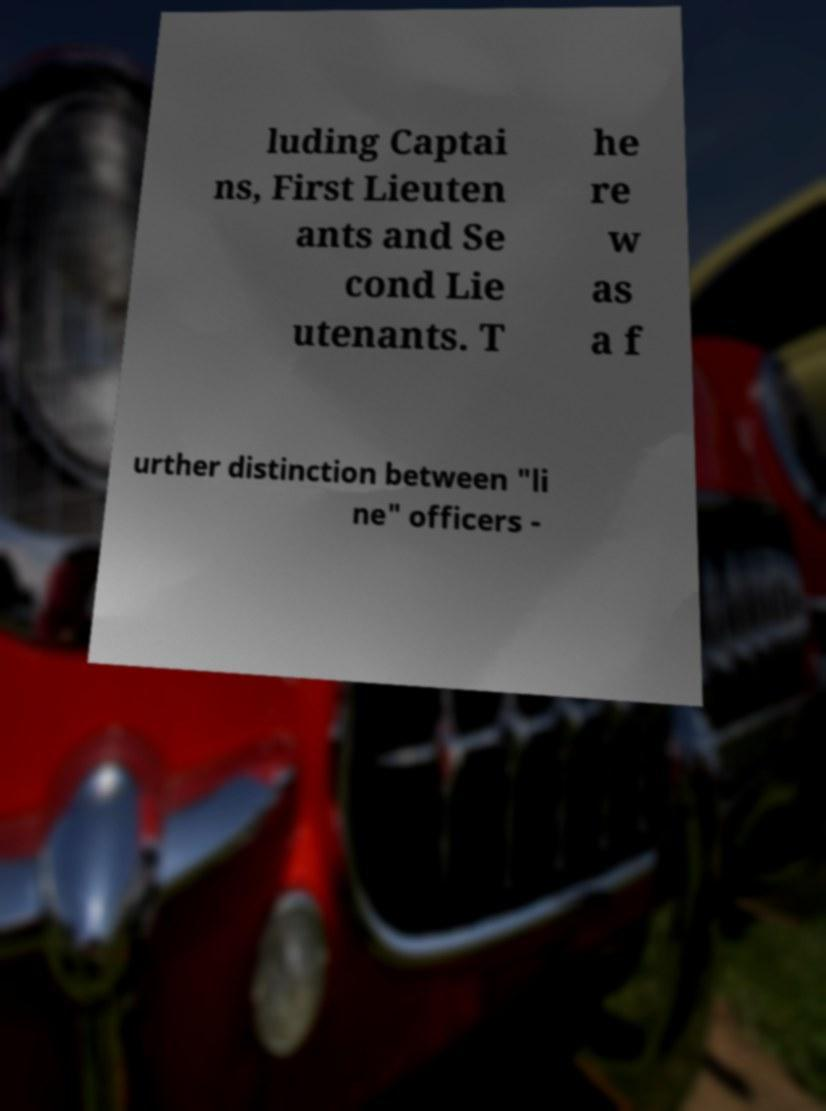I need the written content from this picture converted into text. Can you do that? luding Captai ns, First Lieuten ants and Se cond Lie utenants. T he re w as a f urther distinction between "li ne" officers - 